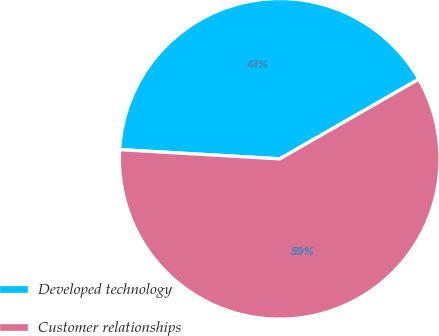Convert chart to OTSL. <chart><loc_0><loc_0><loc_500><loc_500><pie_chart><fcel>Developed technology<fcel>Customer relationships<nl><fcel>40.8%<fcel>59.2%<nl></chart> 